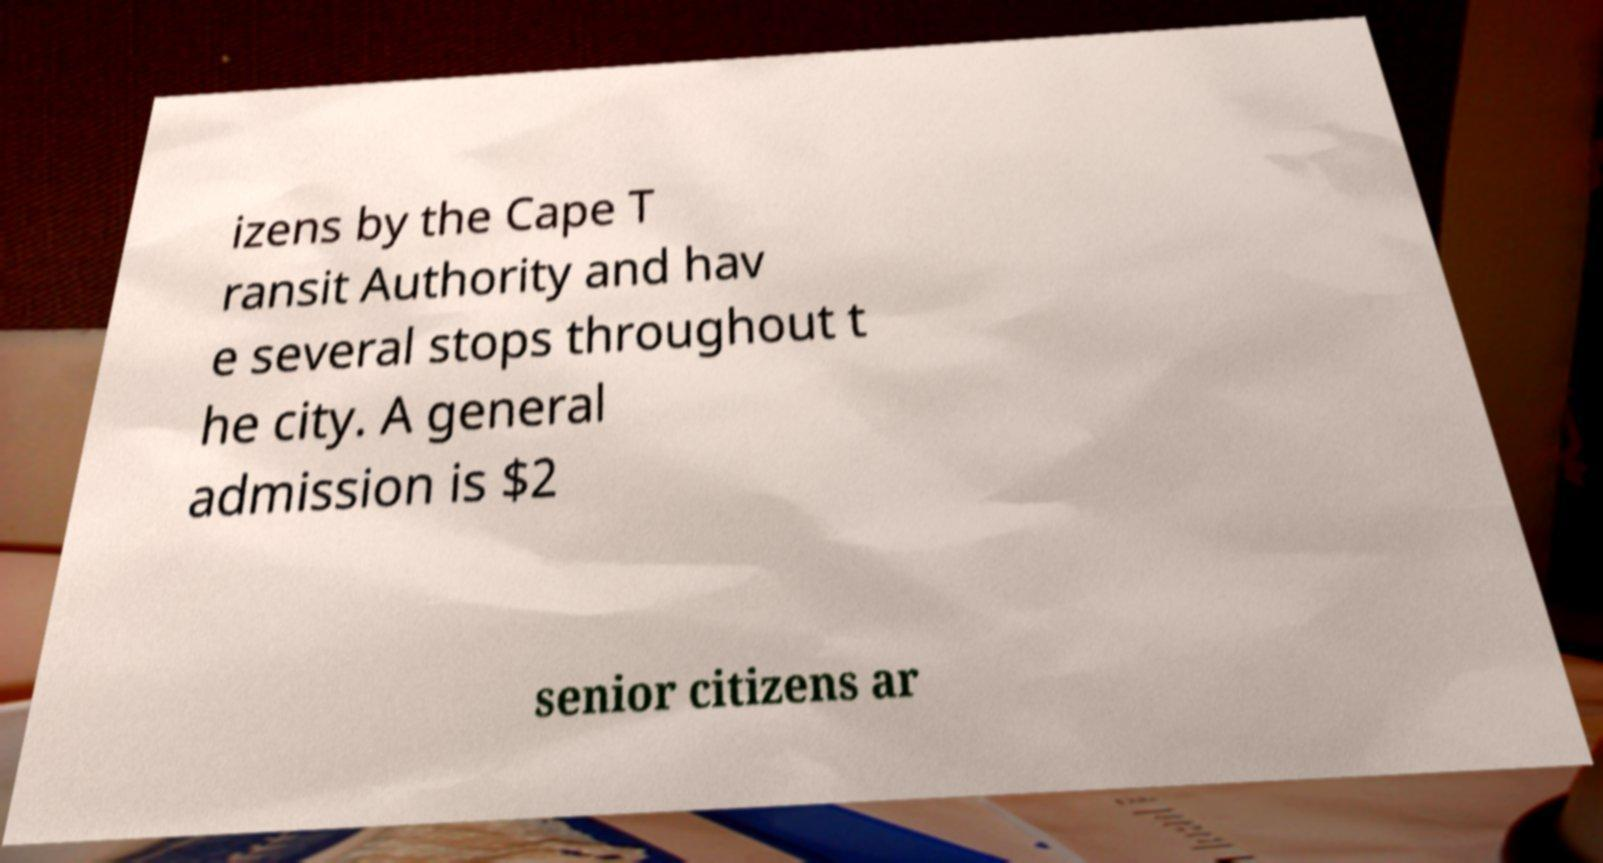What messages or text are displayed in this image? I need them in a readable, typed format. izens by the Cape T ransit Authority and hav e several stops throughout t he city. A general admission is $2 senior citizens ar 